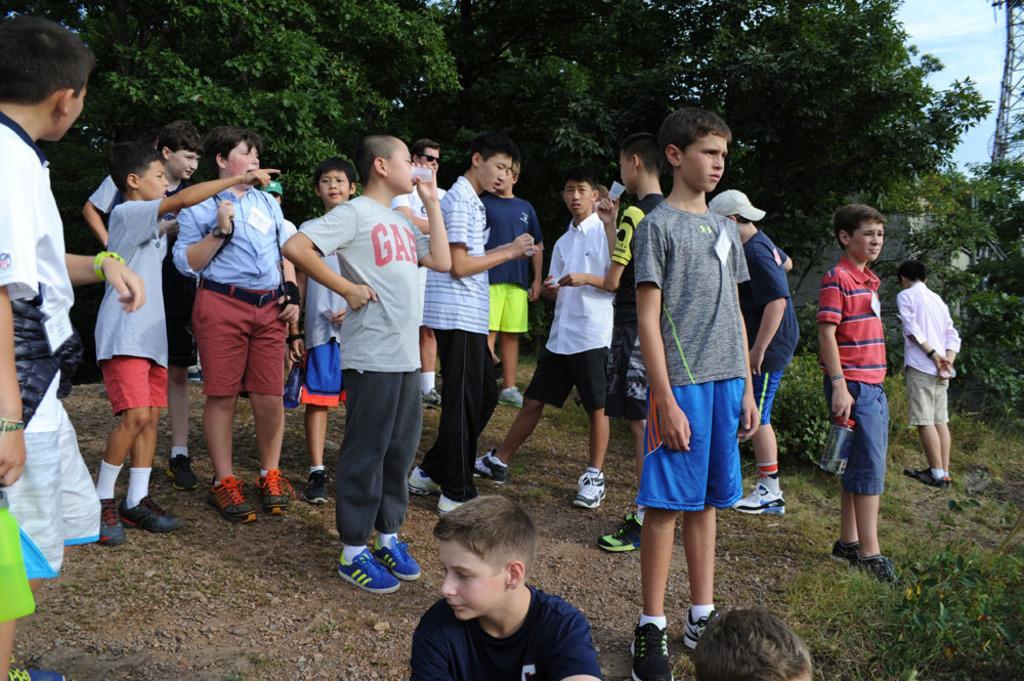Could you give a brief overview of what you see in this image? In this image we can see few persons are standing and at the bottom we can see a person and another person´s head. In the background we can see plants, trees, tower and clouds in the sky. 